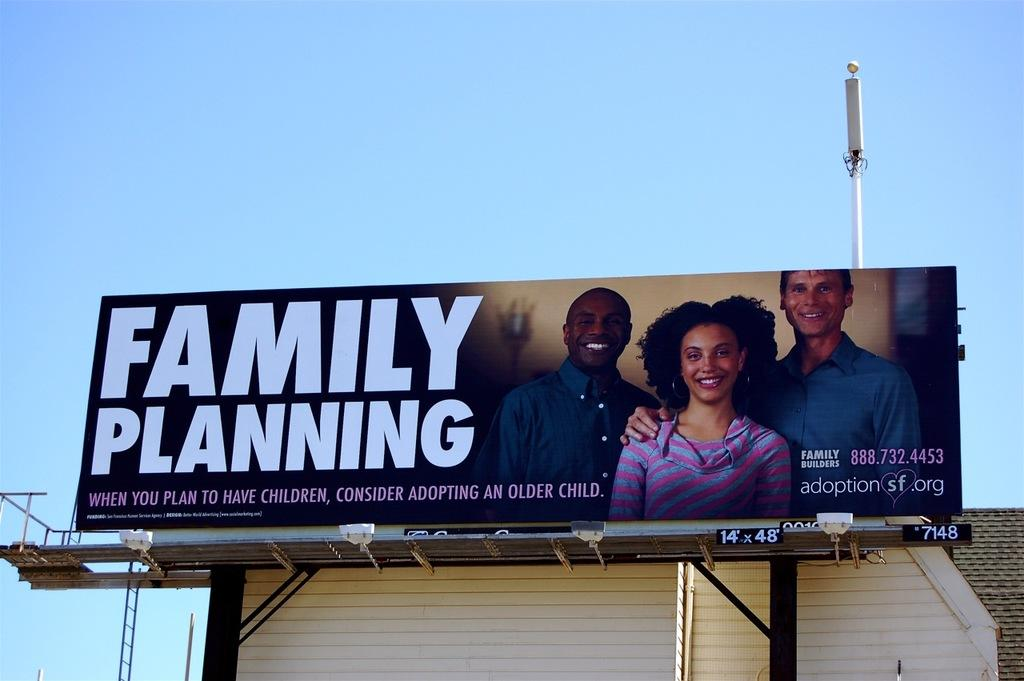<image>
Present a compact description of the photo's key features. Billboard outdoors that says "Family Planning" on it. 